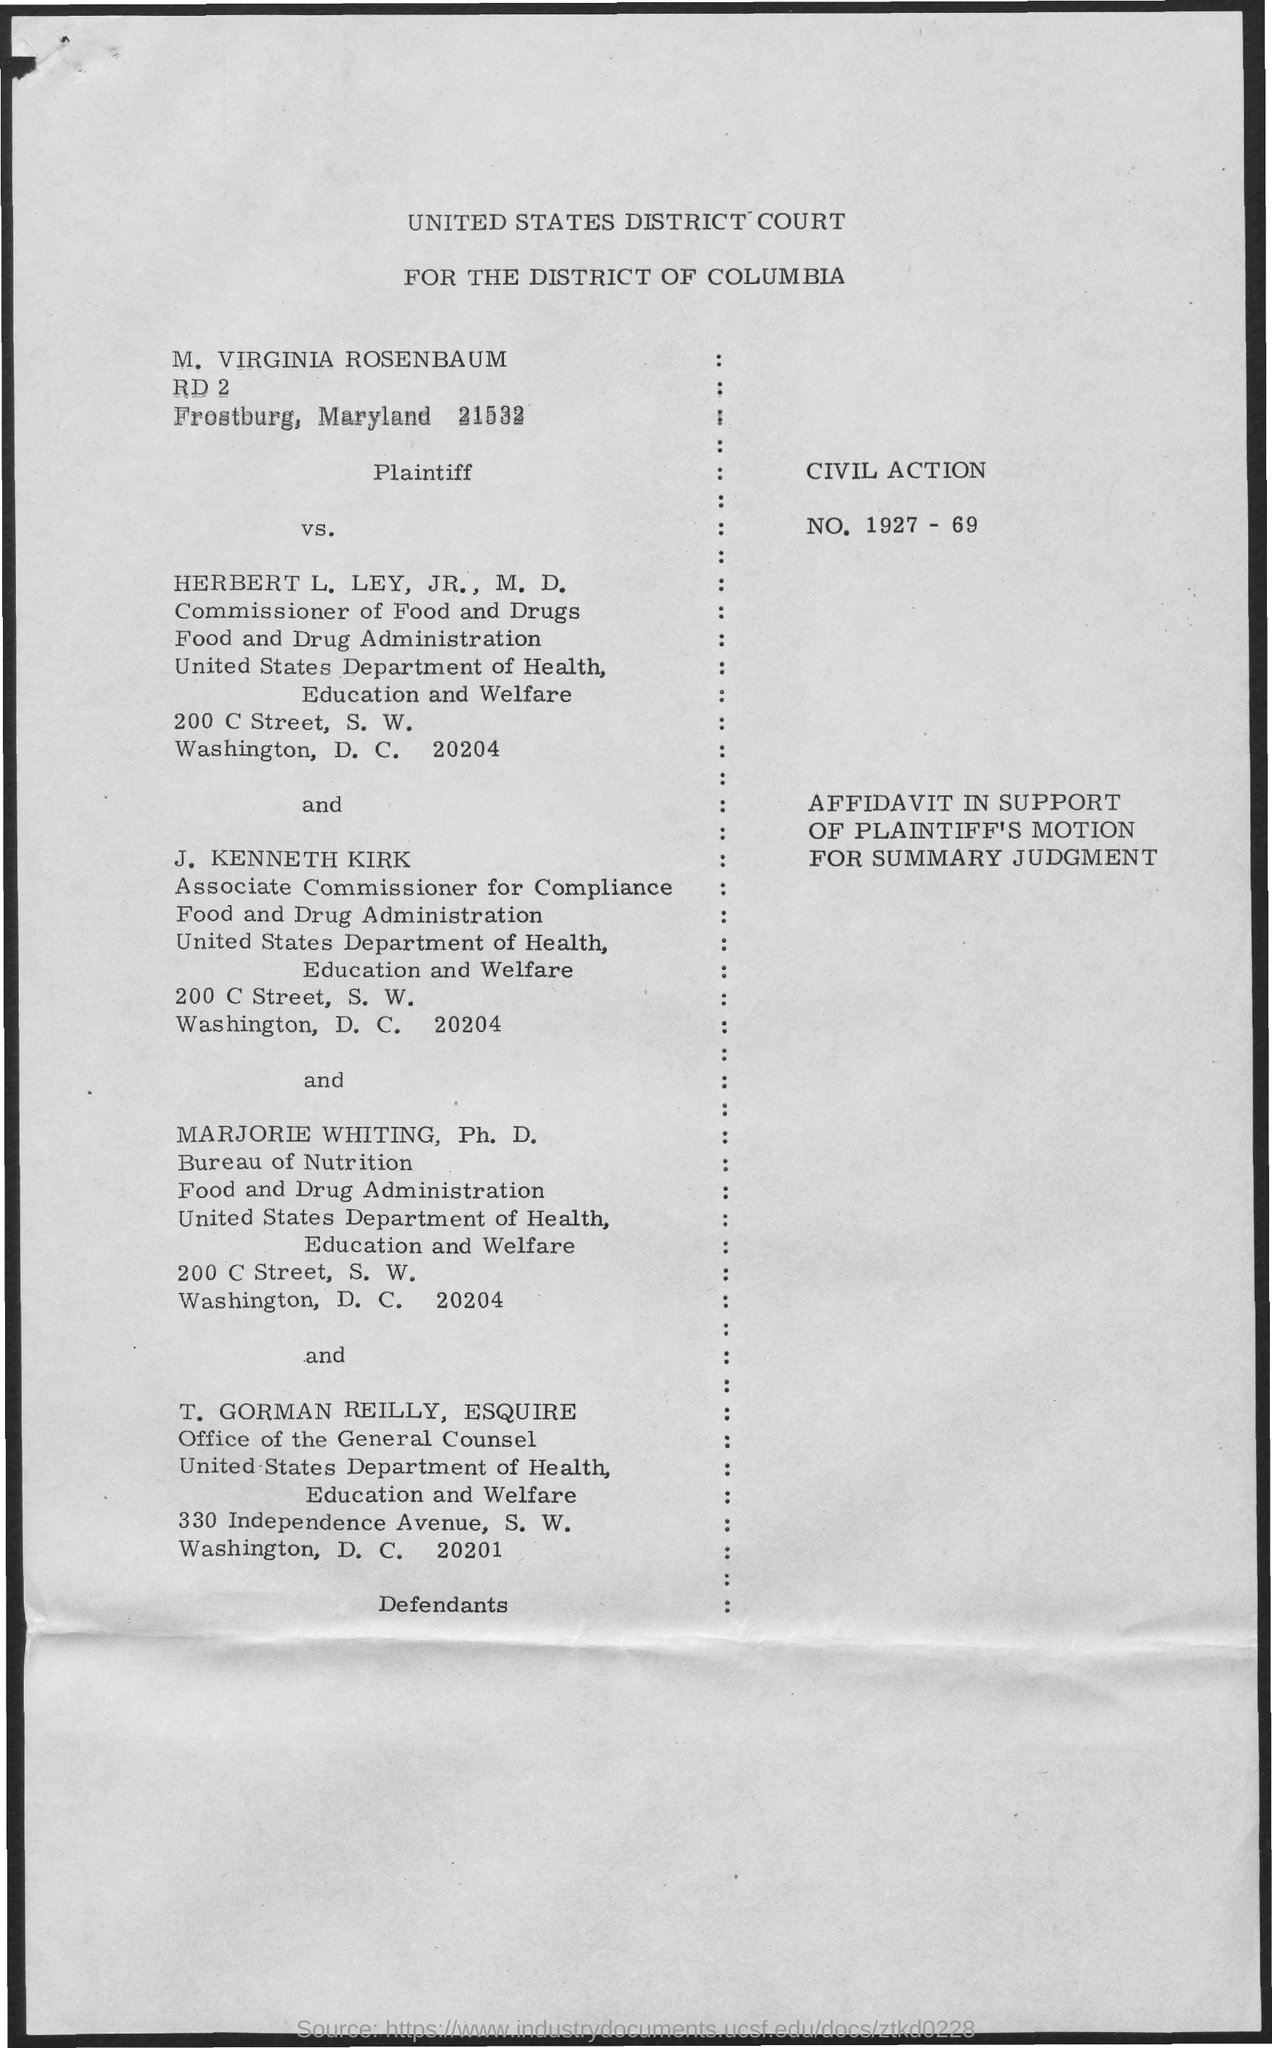Point out several critical features in this image. The Associate Commissioner for Compliance is J. Kenneth Kirk. The title mentions the UNITED STATES DISTRICT COURT FOR THE DISTRICT OF COLUMBIA. The Plaintiff in this civil action is... Herbert L. Ley, Jr., M.D. is the Commissioner of Food and Drugs. 